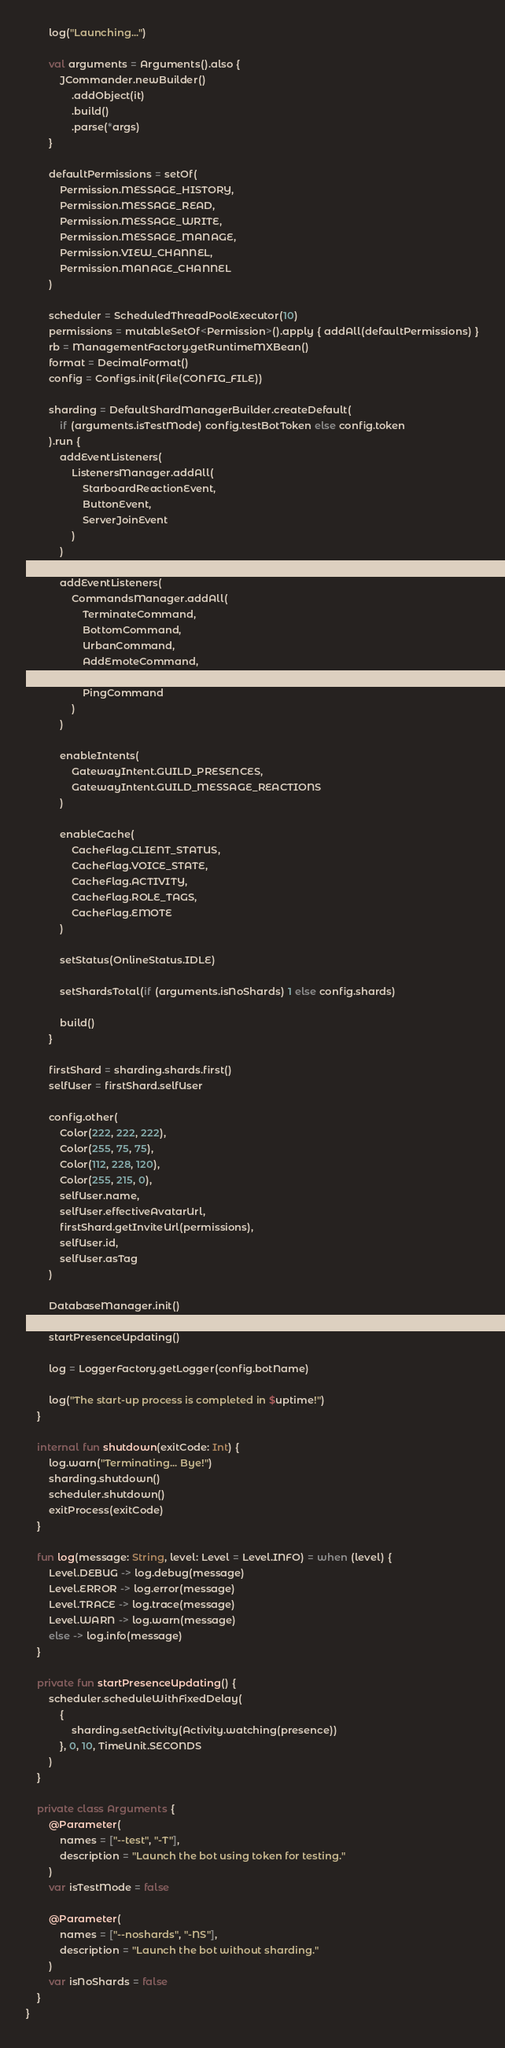<code> <loc_0><loc_0><loc_500><loc_500><_Kotlin_>        log("Launching...")

        val arguments = Arguments().also {
            JCommander.newBuilder()
                .addObject(it)
                .build()
                .parse(*args)
        }

        defaultPermissions = setOf(
            Permission.MESSAGE_HISTORY,
            Permission.MESSAGE_READ,
            Permission.MESSAGE_WRITE,
            Permission.MESSAGE_MANAGE,
            Permission.VIEW_CHANNEL,
            Permission.MANAGE_CHANNEL
        )

        scheduler = ScheduledThreadPoolExecutor(10)
        permissions = mutableSetOf<Permission>().apply { addAll(defaultPermissions) }
        rb = ManagementFactory.getRuntimeMXBean()
        format = DecimalFormat()
        config = Configs.init(File(CONFIG_FILE))

        sharding = DefaultShardManagerBuilder.createDefault(
            if (arguments.isTestMode) config.testBotToken else config.token
        ).run {
            addEventListeners(
                ListenersManager.addAll(
                    StarboardReactionEvent,
                    ButtonEvent,
                    ServerJoinEvent
                )
            )

            addEventListeners(
                CommandsManager.addAll(
                    TerminateCommand,
                    BottomCommand,
                    UrbanCommand,
                    AddEmoteCommand,
                    HelpCommand,
                    PingCommand
                )
            )

            enableIntents(
                GatewayIntent.GUILD_PRESENCES,
                GatewayIntent.GUILD_MESSAGE_REACTIONS
            )

            enableCache(
                CacheFlag.CLIENT_STATUS,
                CacheFlag.VOICE_STATE,
                CacheFlag.ACTIVITY,
                CacheFlag.ROLE_TAGS,
                CacheFlag.EMOTE
            )

            setStatus(OnlineStatus.IDLE)

            setShardsTotal(if (arguments.isNoShards) 1 else config.shards)

            build()
        }

        firstShard = sharding.shards.first()
        selfUser = firstShard.selfUser

        config.other(
            Color(222, 222, 222),
            Color(255, 75, 75),
            Color(112, 228, 120),
            Color(255, 215, 0),
            selfUser.name,
            selfUser.effectiveAvatarUrl,
            firstShard.getInviteUrl(permissions),
            selfUser.id,
            selfUser.asTag
        )

        DatabaseManager.init()
        CooldownsManager.startUpdating()
        startPresenceUpdating()

        log = LoggerFactory.getLogger(config.botName)

        log("The start-up process is completed in $uptime!")
    }

    internal fun shutdown(exitCode: Int) {
        log.warn("Terminating... Bye!")
        sharding.shutdown()
        scheduler.shutdown()
        exitProcess(exitCode)
    }

    fun log(message: String, level: Level = Level.INFO) = when (level) {
        Level.DEBUG -> log.debug(message)
        Level.ERROR -> log.error(message)
        Level.TRACE -> log.trace(message)
        Level.WARN -> log.warn(message)
        else -> log.info(message)
    }

    private fun startPresenceUpdating() {
        scheduler.scheduleWithFixedDelay(
            {
                sharding.setActivity(Activity.watching(presence))
            }, 0, 10, TimeUnit.SECONDS
        )
    }

    private class Arguments {
        @Parameter(
            names = ["--test", "-T"],
            description = "Launch the bot using token for testing."
        )
        var isTestMode = false

        @Parameter(
            names = ["--noshards", "-NS"],
            description = "Launch the bot without sharding."
        )
        var isNoShards = false
    }
}</code> 